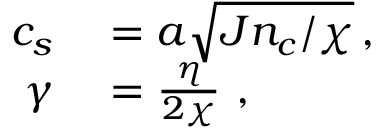Convert formula to latex. <formula><loc_0><loc_0><loc_500><loc_500>\begin{array} { r l } { c _ { s } } & = a \sqrt { J n _ { c } / \chi } \, , } \\ { \gamma } & = \frac { \eta } { 2 \chi } \ , } \end{array}</formula> 